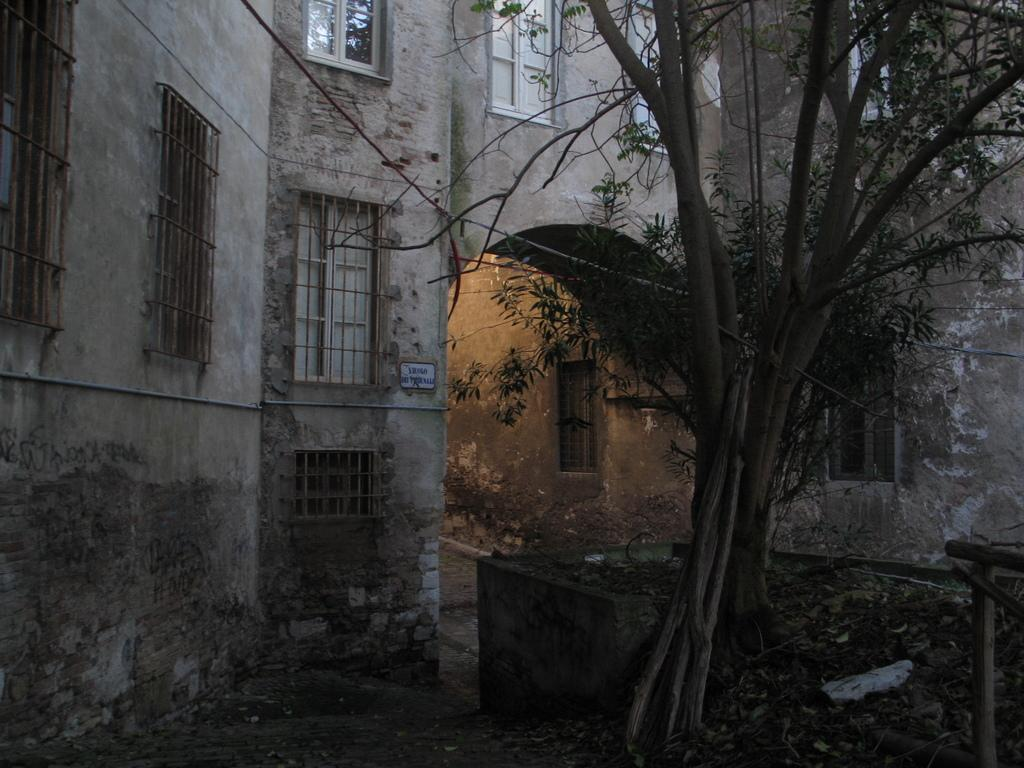What type of structure can be seen in the background of the image? There is a building in the background of the image. What feature of the building is mentioned in the facts? The building has windows. What is located in front of the building? There is a tree in front of the building. What can be found on the ground near the tree? Dry leaves are present on the ground. What is the chance of teaching a class in the building shown in the image? The facts provided do not give any information about the purpose or function of the building, so we cannot determine the chance of teaching a class in the building shown in the image. 